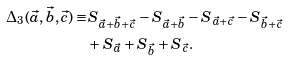<formula> <loc_0><loc_0><loc_500><loc_500>\Delta _ { 3 } ( \vec { a } , \vec { b } , \vec { c } ) \equiv & S _ { \vec { a } + \vec { b } + \vec { c } } - S _ { \vec { a } + \vec { b } } - S _ { \vec { a } + \vec { c } } - S _ { \vec { b } + \vec { c } } \\ & + S _ { \vec { a } } + S _ { \vec { b } } + S _ { \vec { c } } .</formula> 